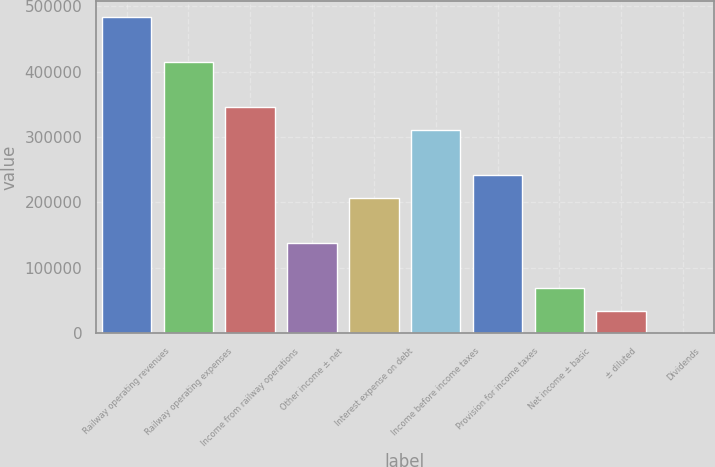<chart> <loc_0><loc_0><loc_500><loc_500><bar_chart><fcel>Railway operating revenues<fcel>Railway operating expenses<fcel>Income from railway operations<fcel>Other income ± net<fcel>Interest expense on debt<fcel>Income before income taxes<fcel>Provision for income taxes<fcel>Net income ± basic<fcel>± diluted<fcel>Dividends<nl><fcel>483677<fcel>414580<fcel>345484<fcel>138195<fcel>207291<fcel>310936<fcel>241839<fcel>69098.1<fcel>34549.9<fcel>1.66<nl></chart> 